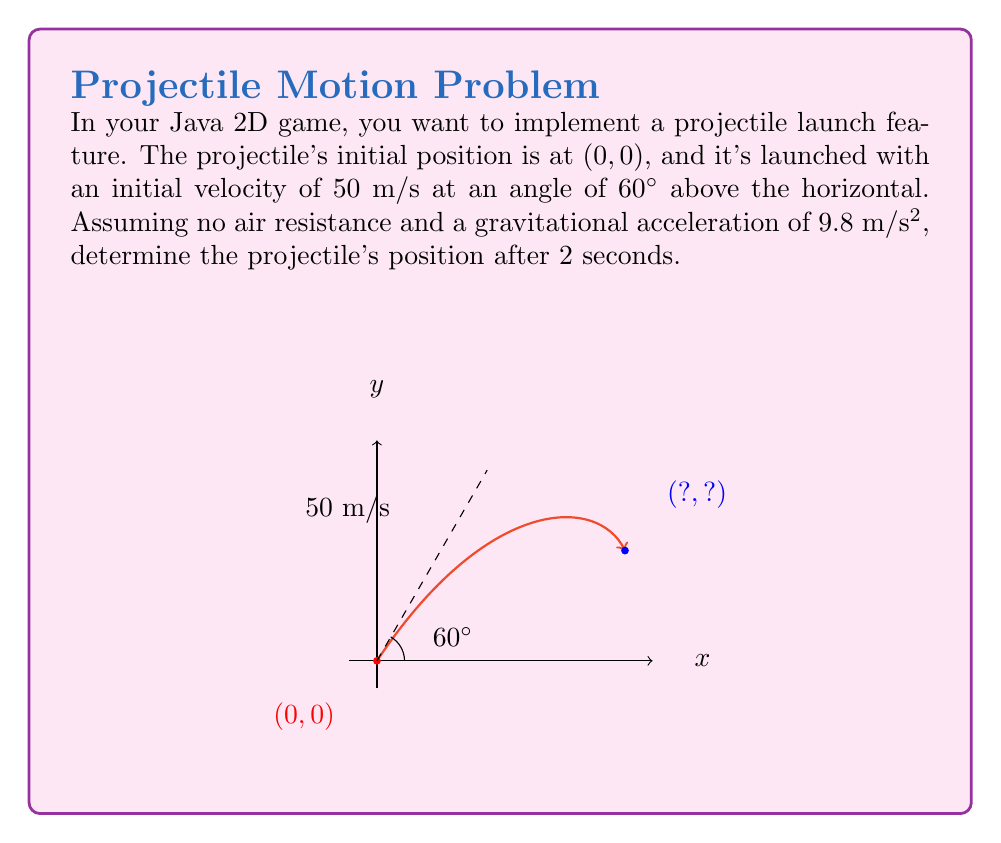Give your solution to this math problem. Let's approach this step-by-step using the second-order equations for projectile motion:

1) The horizontal position $x$ and vertical position $y$ are given by:

   $$x(t) = x_0 + v_0\cos(\theta)t$$
   $$y(t) = y_0 + v_0\sin(\theta)t - \frac{1}{2}gt^2$$

   where $x_0$ and $y_0$ are initial positions, $v_0$ is initial velocity, $\theta$ is launch angle, $g$ is gravitational acceleration, and $t$ is time.

2) Given information:
   - $x_0 = 0$, $y_0 = 0$
   - $v_0 = 50$ m/s
   - $\theta = 60°$ (we need to convert this to radians)
   - $g = 9.8$ m/s²
   - $t = 2$ s

3) Convert 60° to radians:
   $$60° \times \frac{\pi}{180°} = \frac{\pi}{3}$$ radians

4) Calculate $x$ position:
   $$x(2) = 0 + 50 \cos(\frac{\pi}{3}) \times 2$$
   $$= 100 \cos(\frac{\pi}{3}) = 100 \times 0.5 = 50$$ m

5) Calculate $y$ position:
   $$y(2) = 0 + 50 \sin(\frac{\pi}{3}) \times 2 - \frac{1}{2} \times 9.8 \times 2^2$$
   $$= 100 \sin(\frac{\pi}{3}) - 19.6$$
   $$= 100 \times \frac{\sqrt{3}}{2} - 19.6$$
   $$= 50\sqrt{3} - 19.6 \approx 66.91$$ m

Therefore, after 2 seconds, the projectile's position is approximately (50 m, 66.91 m).
Answer: (50, 66.91) 